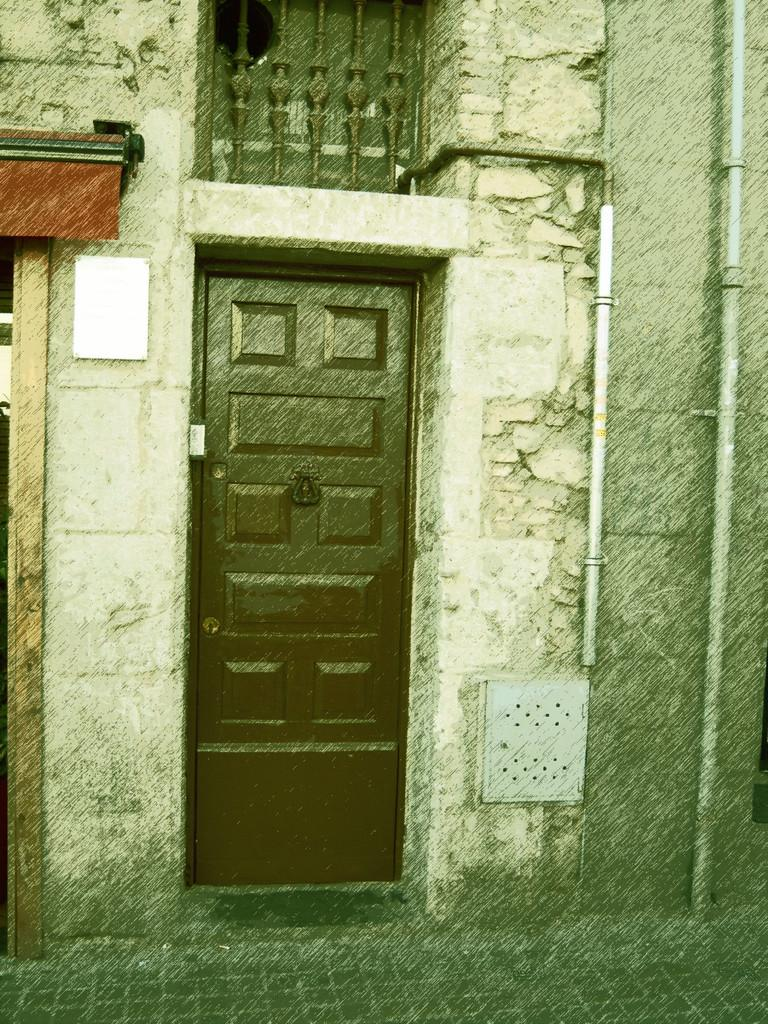What type of door is visible in the image? There is a wooden door in the image. To which structure does the wooden door belong? The wooden door belongs to a house. What can be seen on the wall of a building in the image? There are pipelines on the wall of a building in the image. On which side of the image is the building with pipelines located? The building with pipelines is on the right side of the image. What type of vacation is the owner of the house planning based on the image? There is no information about the owner of the house or any vacation plans in the image. 